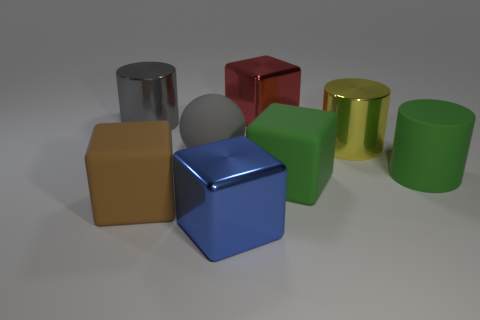Is the number of metallic cubes that are on the left side of the brown cube less than the number of big brown metal cubes? Although your question assumes that the cubes have a metallic texture, it's tricky to determine material properties from the image alone. However, if we consider the cube to the left of the brown cube and compare its size to the brown cubes, it appears that there's only one cube in question and there are two brown cubes of a comparable size. Thus, the number of big brown cubes is greater than the number of cubes to the left of the brown cube. 